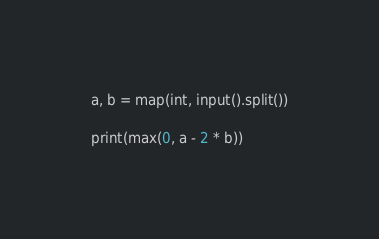<code> <loc_0><loc_0><loc_500><loc_500><_Python_>a, b = map(int, input().split())

print(max(0, a - 2 * b))</code> 